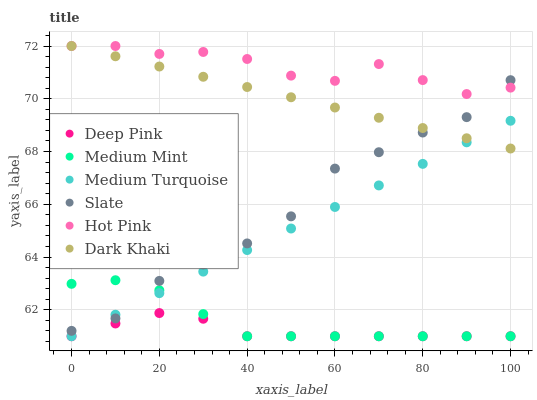Does Deep Pink have the minimum area under the curve?
Answer yes or no. Yes. Does Hot Pink have the maximum area under the curve?
Answer yes or no. Yes. Does Slate have the minimum area under the curve?
Answer yes or no. No. Does Slate have the maximum area under the curve?
Answer yes or no. No. Is Medium Turquoise the smoothest?
Answer yes or no. Yes. Is Slate the roughest?
Answer yes or no. Yes. Is Deep Pink the smoothest?
Answer yes or no. No. Is Deep Pink the roughest?
Answer yes or no. No. Does Medium Mint have the lowest value?
Answer yes or no. Yes. Does Slate have the lowest value?
Answer yes or no. No. Does Dark Khaki have the highest value?
Answer yes or no. Yes. Does Slate have the highest value?
Answer yes or no. No. Is Deep Pink less than Slate?
Answer yes or no. Yes. Is Dark Khaki greater than Deep Pink?
Answer yes or no. Yes. Does Slate intersect Medium Mint?
Answer yes or no. Yes. Is Slate less than Medium Mint?
Answer yes or no. No. Is Slate greater than Medium Mint?
Answer yes or no. No. Does Deep Pink intersect Slate?
Answer yes or no. No. 